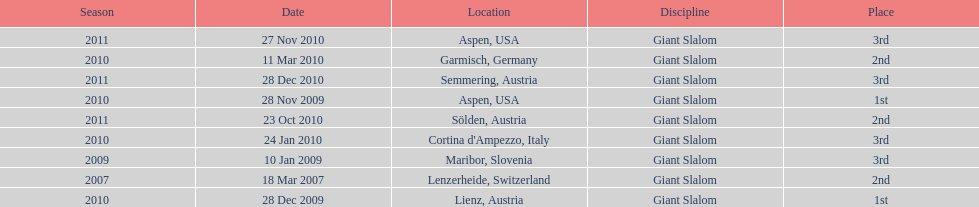Parse the full table. {'header': ['Season', 'Date', 'Location', 'Discipline', 'Place'], 'rows': [['2011', '27 Nov 2010', 'Aspen, USA', 'Giant Slalom', '3rd'], ['2010', '11 Mar 2010', 'Garmisch, Germany', 'Giant Slalom', '2nd'], ['2011', '28 Dec 2010', 'Semmering, Austria', 'Giant Slalom', '3rd'], ['2010', '28 Nov 2009', 'Aspen, USA', 'Giant Slalom', '1st'], ['2011', '23 Oct 2010', 'Sölden, Austria', 'Giant Slalom', '2nd'], ['2010', '24 Jan 2010', "Cortina d'Ampezzo, Italy", 'Giant Slalom', '3rd'], ['2009', '10 Jan 2009', 'Maribor, Slovenia', 'Giant Slalom', '3rd'], ['2007', '18 Mar 2007', 'Lenzerheide, Switzerland', 'Giant Slalom', '2nd'], ['2010', '28 Dec 2009', 'Lienz, Austria', 'Giant Slalom', '1st']]} How many races were in 2010? 5. 